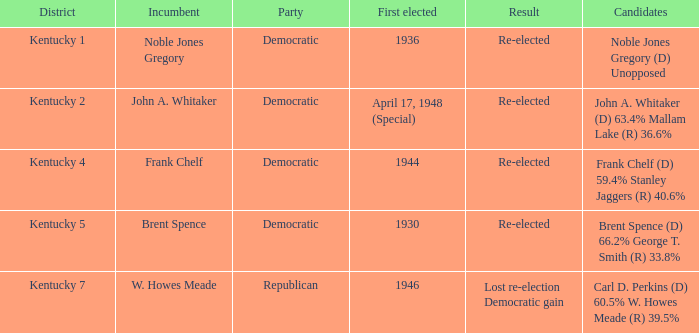List all candidates in the democratic party where the election had the incumbent Frank Chelf running. Frank Chelf (D) 59.4% Stanley Jaggers (R) 40.6%. 